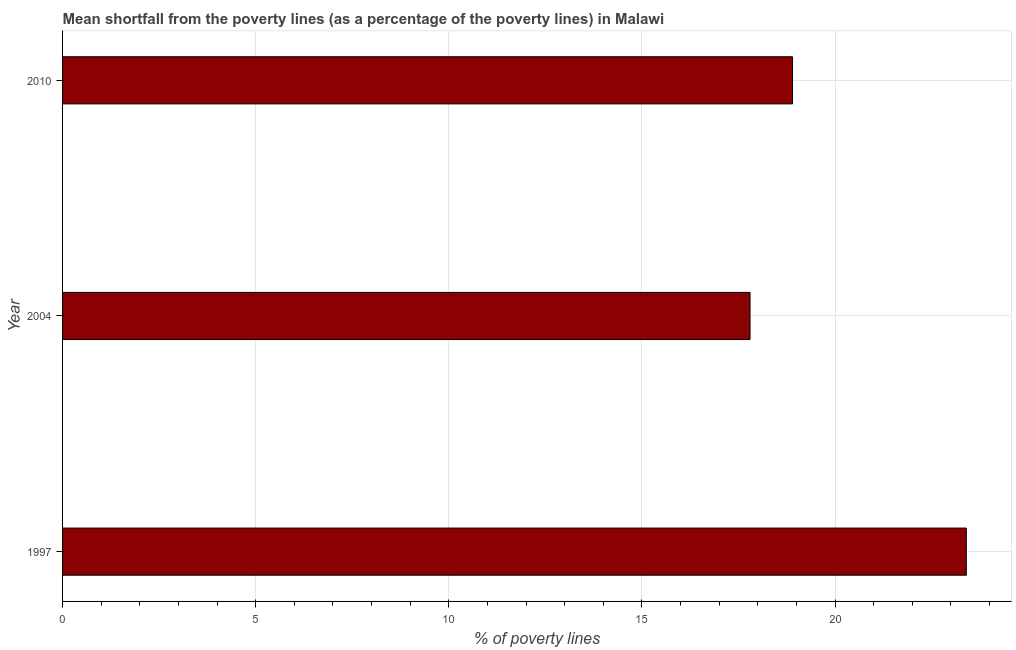Does the graph contain grids?
Provide a short and direct response. Yes. What is the title of the graph?
Ensure brevity in your answer.  Mean shortfall from the poverty lines (as a percentage of the poverty lines) in Malawi. What is the label or title of the X-axis?
Offer a very short reply. % of poverty lines. Across all years, what is the maximum poverty gap at national poverty lines?
Provide a short and direct response. 23.4. In which year was the poverty gap at national poverty lines minimum?
Ensure brevity in your answer.  2004. What is the sum of the poverty gap at national poverty lines?
Your response must be concise. 60.1. What is the average poverty gap at national poverty lines per year?
Ensure brevity in your answer.  20.03. In how many years, is the poverty gap at national poverty lines greater than 16 %?
Keep it short and to the point. 3. Do a majority of the years between 2010 and 2004 (inclusive) have poverty gap at national poverty lines greater than 14 %?
Ensure brevity in your answer.  No. What is the ratio of the poverty gap at national poverty lines in 2004 to that in 2010?
Provide a short and direct response. 0.94. Is the difference between the poverty gap at national poverty lines in 1997 and 2010 greater than the difference between any two years?
Your answer should be very brief. No. What is the difference between the highest and the second highest poverty gap at national poverty lines?
Your answer should be very brief. 4.5. In how many years, is the poverty gap at national poverty lines greater than the average poverty gap at national poverty lines taken over all years?
Your answer should be compact. 1. How many bars are there?
Offer a very short reply. 3. Are all the bars in the graph horizontal?
Offer a very short reply. Yes. How many years are there in the graph?
Make the answer very short. 3. What is the difference between two consecutive major ticks on the X-axis?
Give a very brief answer. 5. What is the % of poverty lines in 1997?
Offer a terse response. 23.4. What is the % of poverty lines in 2010?
Your answer should be compact. 18.9. What is the difference between the % of poverty lines in 2004 and 2010?
Ensure brevity in your answer.  -1.1. What is the ratio of the % of poverty lines in 1997 to that in 2004?
Your response must be concise. 1.31. What is the ratio of the % of poverty lines in 1997 to that in 2010?
Ensure brevity in your answer.  1.24. What is the ratio of the % of poverty lines in 2004 to that in 2010?
Your answer should be very brief. 0.94. 